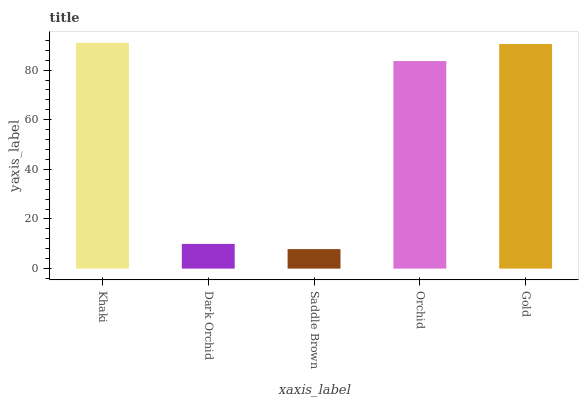Is Saddle Brown the minimum?
Answer yes or no. Yes. Is Khaki the maximum?
Answer yes or no. Yes. Is Dark Orchid the minimum?
Answer yes or no. No. Is Dark Orchid the maximum?
Answer yes or no. No. Is Khaki greater than Dark Orchid?
Answer yes or no. Yes. Is Dark Orchid less than Khaki?
Answer yes or no. Yes. Is Dark Orchid greater than Khaki?
Answer yes or no. No. Is Khaki less than Dark Orchid?
Answer yes or no. No. Is Orchid the high median?
Answer yes or no. Yes. Is Orchid the low median?
Answer yes or no. Yes. Is Khaki the high median?
Answer yes or no. No. Is Gold the low median?
Answer yes or no. No. 